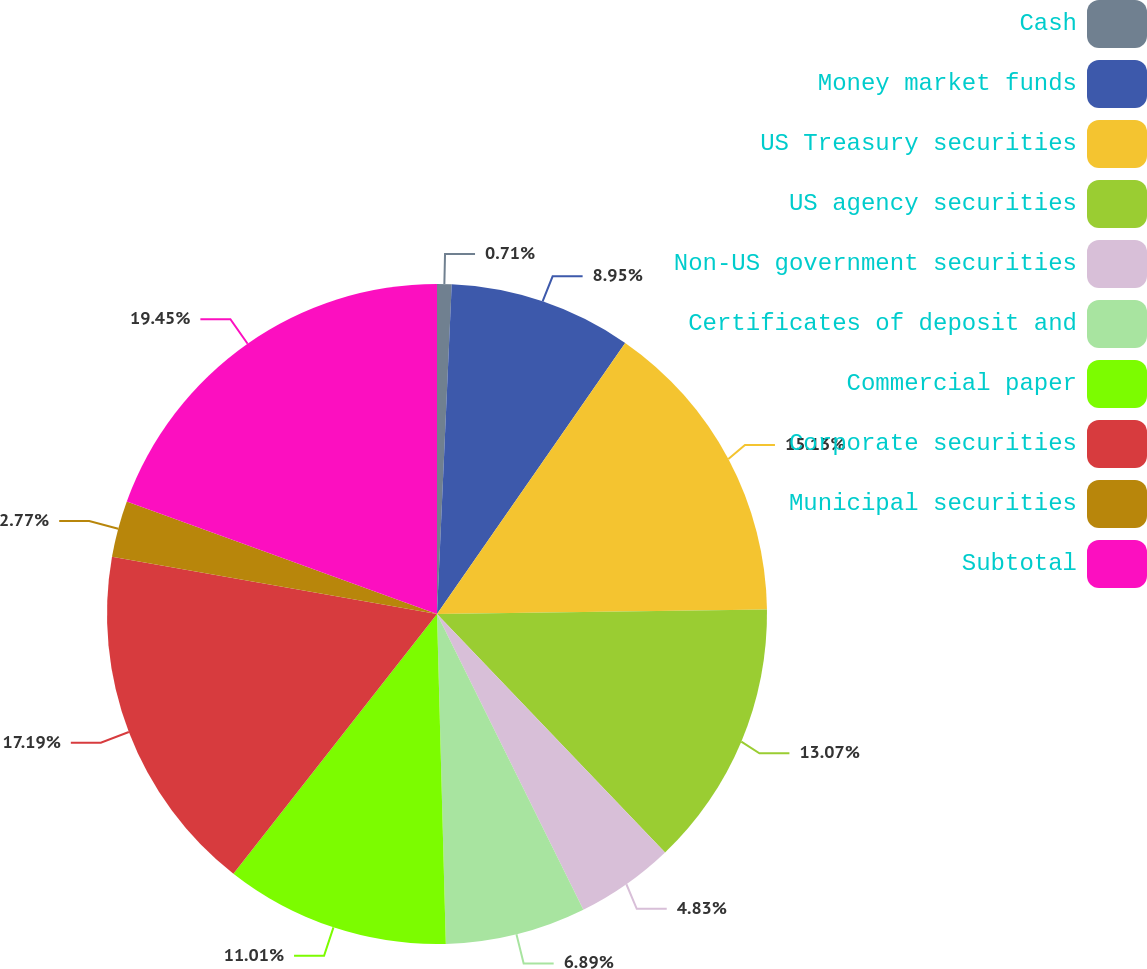Convert chart. <chart><loc_0><loc_0><loc_500><loc_500><pie_chart><fcel>Cash<fcel>Money market funds<fcel>US Treasury securities<fcel>US agency securities<fcel>Non-US government securities<fcel>Certificates of deposit and<fcel>Commercial paper<fcel>Corporate securities<fcel>Municipal securities<fcel>Subtotal<nl><fcel>0.71%<fcel>8.95%<fcel>15.13%<fcel>13.07%<fcel>4.83%<fcel>6.89%<fcel>11.01%<fcel>17.19%<fcel>2.77%<fcel>19.46%<nl></chart> 